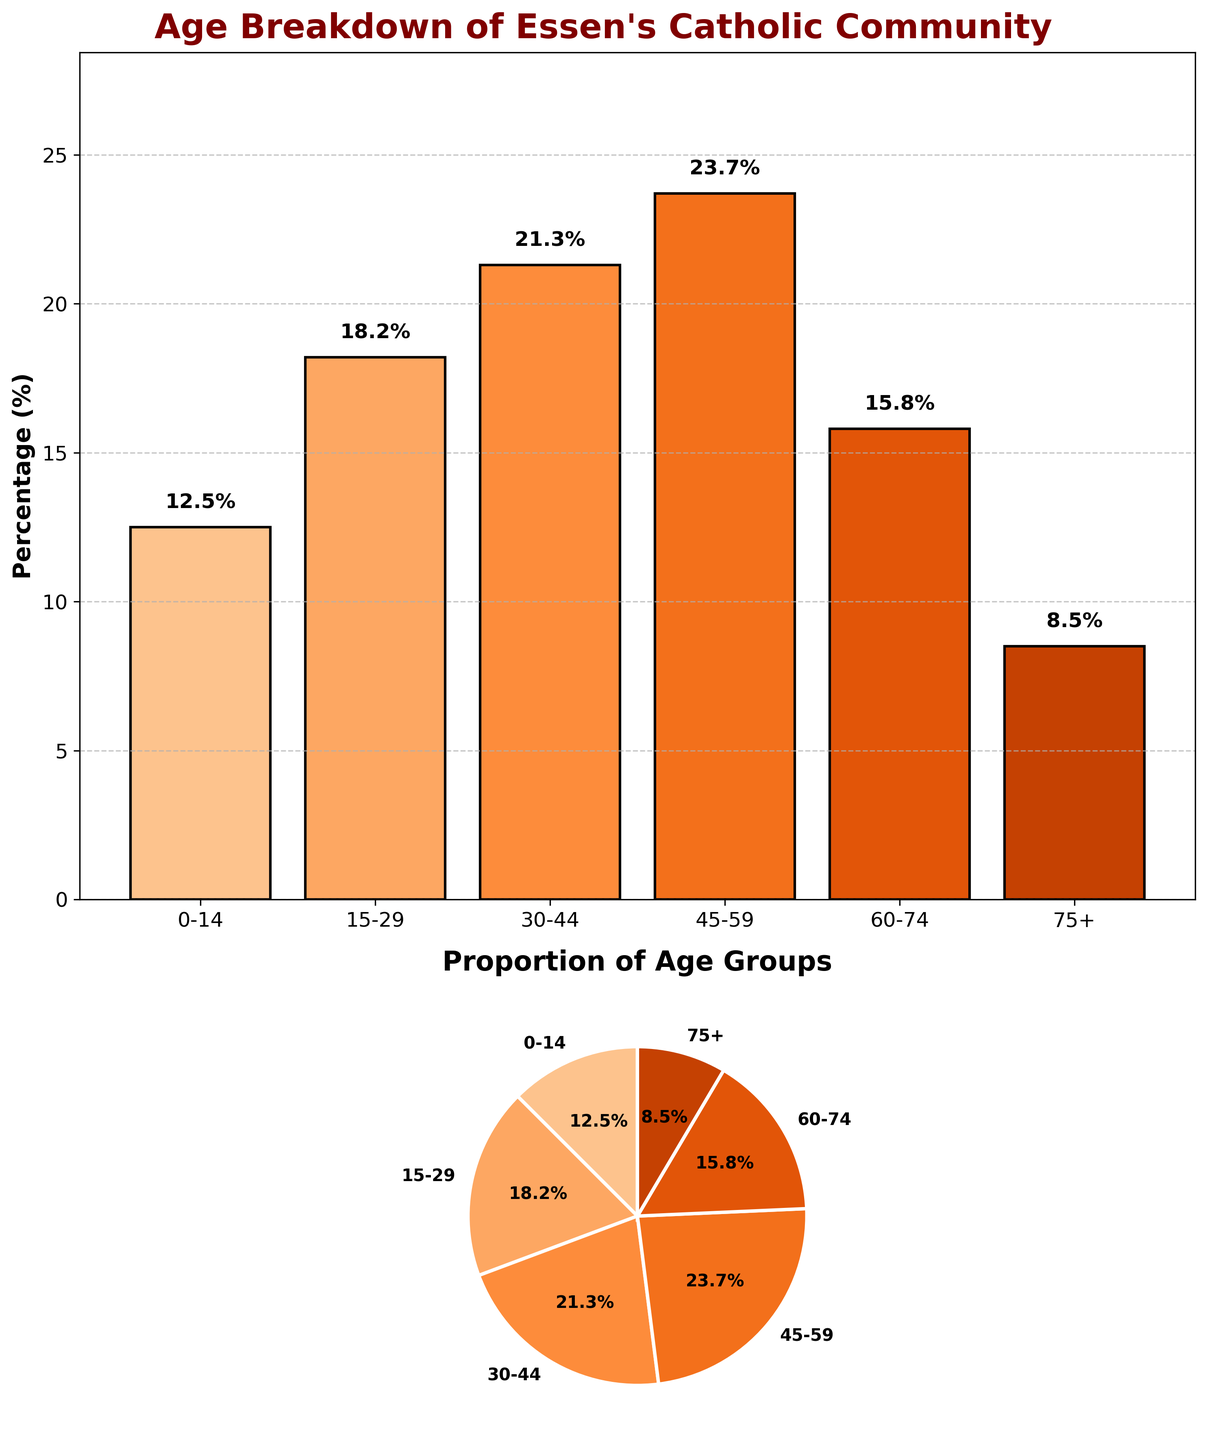What is the title of the figure? The title of the figure is located at the top of the plot and reads "Age Breakdown of Essen's Catholic Community".
Answer: Age Breakdown of Essen's Catholic Community How many age groups are represented in the pie chart? The pie chart displays slices labeled with different age groups. Counting each label, there are six age groups represented.
Answer: Six Which age group has the highest percentage? The bar plot shows different heights for each age group corresponding to their percentages. The tallest bar is "45-59", indicating it has the highest percentage.
Answer: 45-59 What is the percentage of the 60-74 age group? In the bar plot, you can see the label above the bar for the 60-74 age group, which indicates the percentage.
Answer: 15.8% How do the percentages of the youngest (0-14) and oldest (75+) age groups compare? Looking at the bar plot, the height of the bar for the 0-14 age group is taller than the bar for the 75+ age group. Specifically, 0-14 is 12.5% and 75+ is 8.5%.
Answer: 0-14 is higher than 75+ What is the combined percentage of the 30-44 and 45-59 age groups? From the bar plot, add the percentages for 30-44 (21.3%) and 45-59 (23.7%). The combined percentage is 21.3 + 23.7 = 45.0%.
Answer: 45.0% Which age group has the smallest percentage, and what is it? The shortest bar in the bar plot corresponds to the 75+ age group, which has a label indicating its percentage as 8.5%.
Answer: 75+, 8.5% What is the percentage difference between the 15-29 and 60-74 age groups? Subtract the percentage of the 60-74 age group (15.8%) from the 15-29 age group (18.2%). The difference is 18.2 - 15.8 = 2.4%.
Answer: 2.4% Which age group’s proportion is closest to the median age group percentage? Listing the percentages: 12.5%, 18.2%, 21.3%, 23.7%, 15.8%, 8.5%, the median percentage falls around 18.2% (15-29) or 21.3% (30-44). The 15-29 percentage (18.2%) is closest to the median.
Answer: 15-29 How does the sum of the 0-14 and 75+ age groups' percentages compare to the 45-59 age group’s percentage? Add the percentages of the 0-14 (12.5%) and 75+ (8.5%) age groups. The sum is 12.5 + 8.5 = 21.0%. Compare this to the 45-59 percentage (23.7%), 21.0% is less than 23.7%.
Answer: Combined is less 